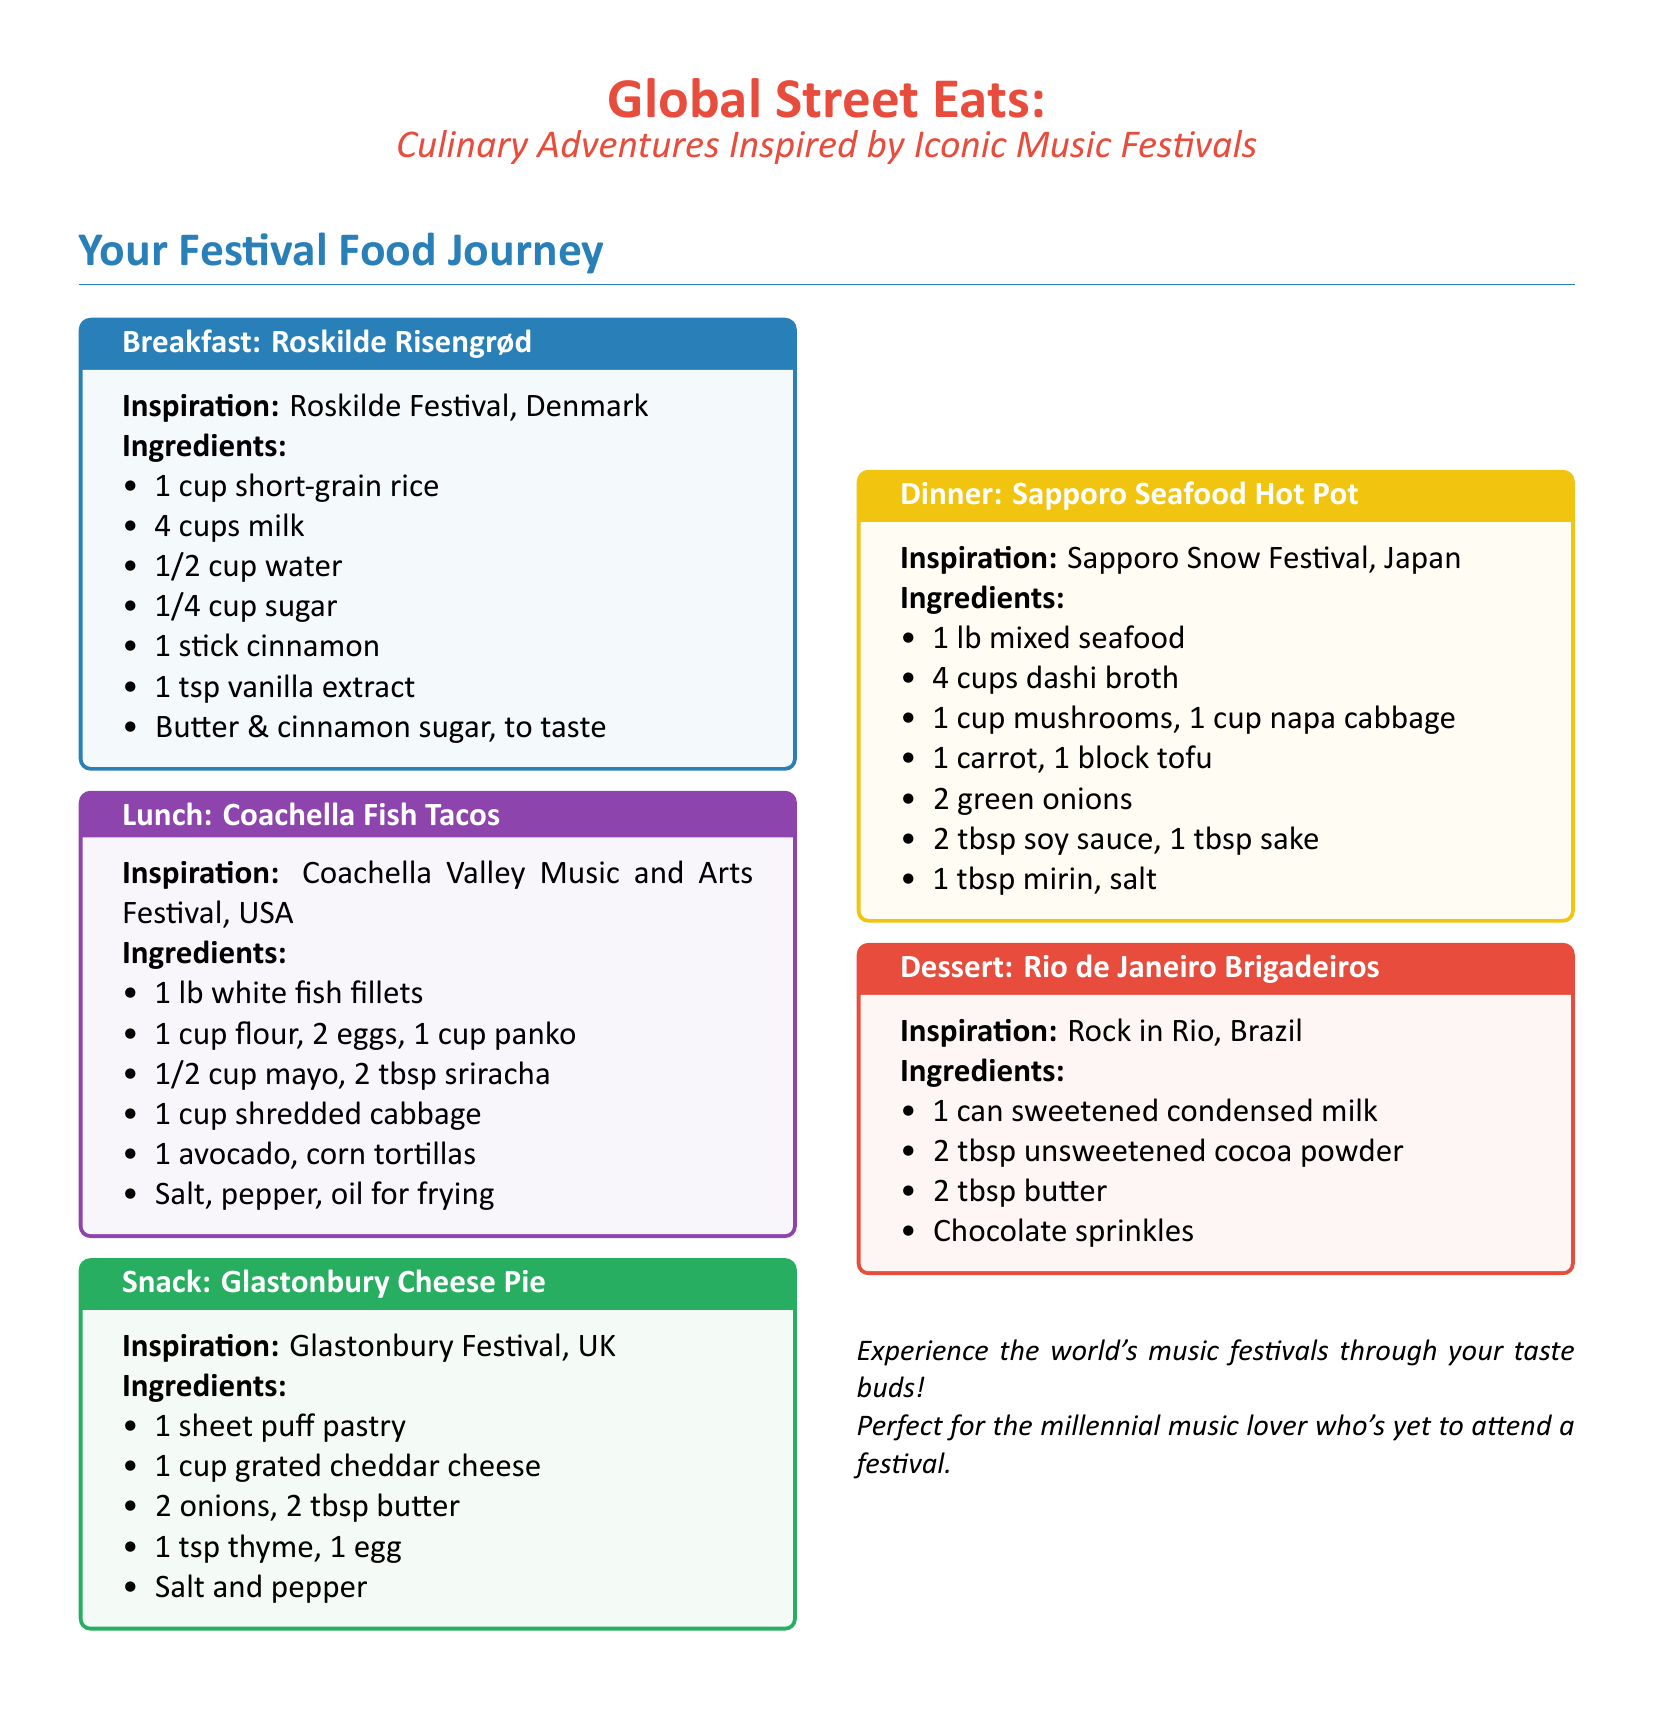What is the breakfast dish inspired by Roskilde Festival? The breakfast dish is Rizengrød, which is a traditional rice pudding.
Answer: Roskilde Risengrød How many ingredients are in the Coachella Fish Tacos recipe? The ingredients are listed in the document as a series, and counting them reveals there are six ingredients.
Answer: 6 What type of pastry is used in the Glastonbury Cheese Pie? The document specifies that puff pastry is used in the recipe.
Answer: Puff pastry What is the main seafood dish featured for dinner? The name of the dinner dish inspired by the Sapporo Snow Festival is provided.
Answer: Sapporo Seafood Hot Pot What festival inspired the dessert Brigadeiros? The document lists the festival associated with Brigadeiros.
Answer: Rock in Rio Which ingredient is required for the Roskilde Risengrød? The ingredients list for the breakfast dish includes specific items, one of which is needed for preparation.
Answer: Short-grain rice What is the main ingredient in the Sapporo Seafood Hot Pot's broth? The document indicates the type of broth used in the dish.
Answer: Dashi broth What type of cuisine do these meals represent? The meals inspired by music festivals reflect a mix of international street food.
Answer: Street food 